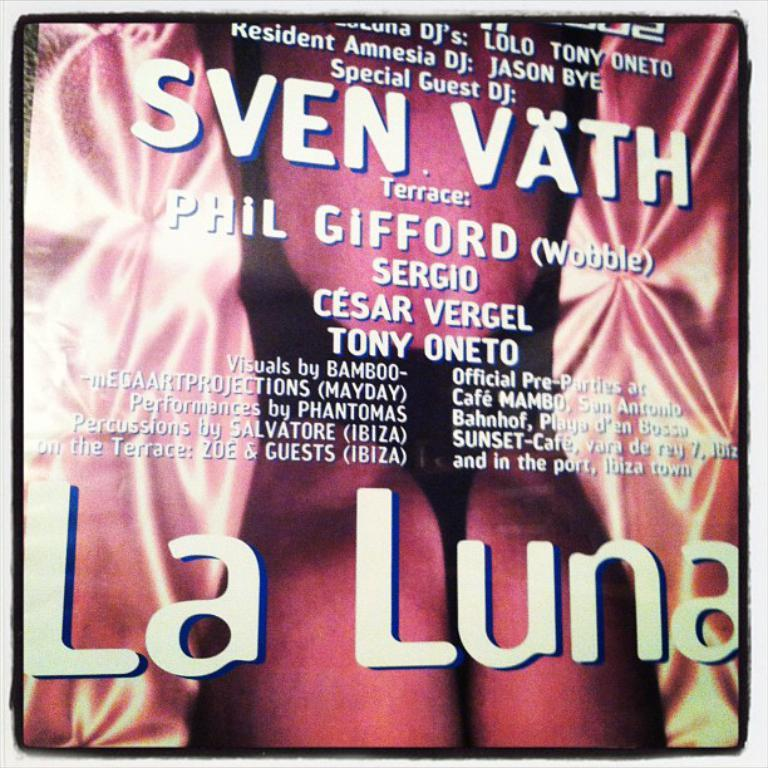Provide a one-sentence caption for the provided image. A cover that says La Luna and Sven Vath. 